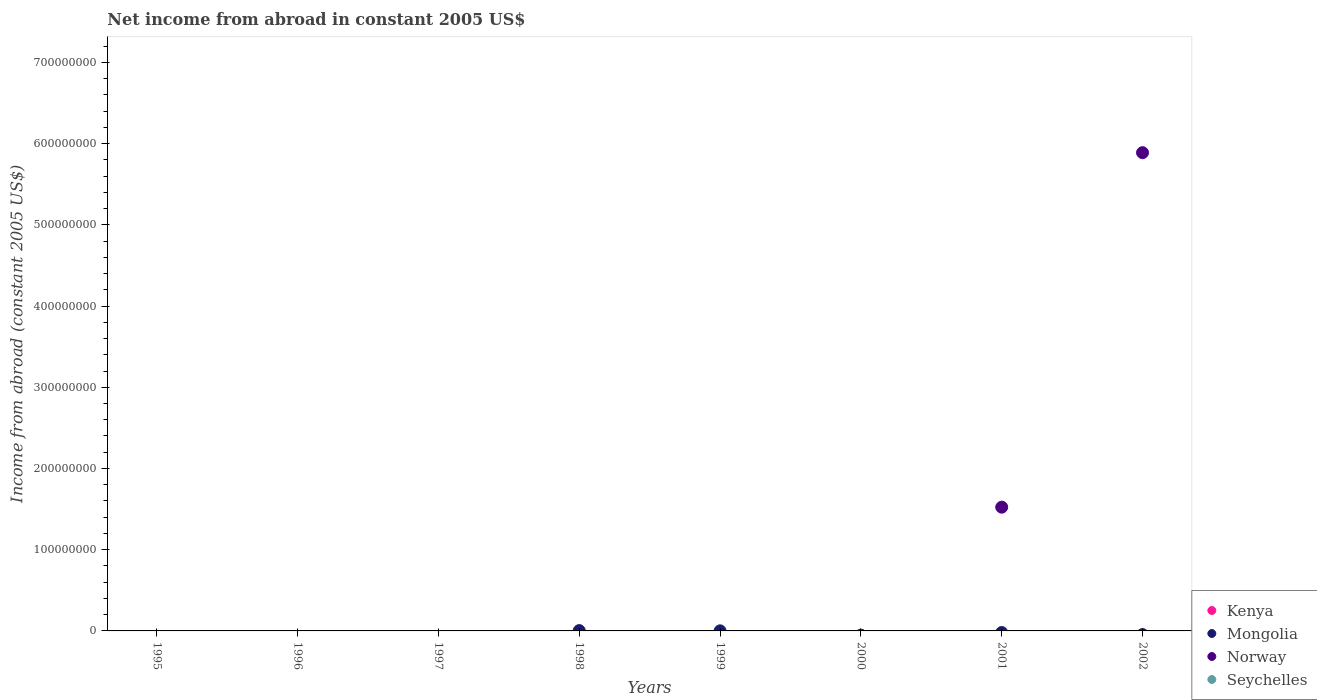Across all years, what is the maximum net income from abroad in Mongolia?
Your response must be concise. 4.00e+05. Across all years, what is the minimum net income from abroad in Norway?
Your response must be concise. 0. In which year was the net income from abroad in Mongolia maximum?
Ensure brevity in your answer.  1998. What is the total net income from abroad in Mongolia in the graph?
Give a very brief answer. 5.00e+05. What is the difference between the net income from abroad in Mongolia in 1995 and the net income from abroad in Seychelles in 1999?
Ensure brevity in your answer.  0. What is the average net income from abroad in Kenya per year?
Ensure brevity in your answer.  0. What is the difference between the highest and the lowest net income from abroad in Mongolia?
Your answer should be very brief. 4.00e+05. Is it the case that in every year, the sum of the net income from abroad in Kenya and net income from abroad in Seychelles  is greater than the sum of net income from abroad in Mongolia and net income from abroad in Norway?
Your answer should be very brief. No. Is it the case that in every year, the sum of the net income from abroad in Norway and net income from abroad in Seychelles  is greater than the net income from abroad in Kenya?
Keep it short and to the point. No. Is the net income from abroad in Seychelles strictly greater than the net income from abroad in Kenya over the years?
Keep it short and to the point. Yes. Is the net income from abroad in Seychelles strictly less than the net income from abroad in Mongolia over the years?
Your answer should be very brief. No. Does the graph contain any zero values?
Your response must be concise. Yes. What is the title of the graph?
Make the answer very short. Net income from abroad in constant 2005 US$. What is the label or title of the Y-axis?
Your response must be concise. Income from abroad (constant 2005 US$). What is the Income from abroad (constant 2005 US$) of Norway in 1995?
Ensure brevity in your answer.  0. What is the Income from abroad (constant 2005 US$) in Kenya in 1996?
Your answer should be very brief. 0. What is the Income from abroad (constant 2005 US$) of Seychelles in 1996?
Provide a succinct answer. 0. What is the Income from abroad (constant 2005 US$) of Mongolia in 1997?
Offer a very short reply. 0. What is the Income from abroad (constant 2005 US$) of Norway in 1997?
Offer a very short reply. 0. What is the Income from abroad (constant 2005 US$) in Seychelles in 1997?
Keep it short and to the point. 0. What is the Income from abroad (constant 2005 US$) in Mongolia in 1998?
Provide a short and direct response. 4.00e+05. What is the Income from abroad (constant 2005 US$) of Norway in 1998?
Provide a succinct answer. 0. What is the Income from abroad (constant 2005 US$) of Seychelles in 1998?
Offer a very short reply. 0. What is the Income from abroad (constant 2005 US$) in Mongolia in 1999?
Provide a succinct answer. 1.00e+05. What is the Income from abroad (constant 2005 US$) of Norway in 1999?
Offer a terse response. 0. What is the Income from abroad (constant 2005 US$) in Seychelles in 1999?
Offer a very short reply. 0. What is the Income from abroad (constant 2005 US$) in Kenya in 2000?
Make the answer very short. 0. What is the Income from abroad (constant 2005 US$) of Norway in 2000?
Make the answer very short. 0. What is the Income from abroad (constant 2005 US$) in Mongolia in 2001?
Offer a terse response. 0. What is the Income from abroad (constant 2005 US$) of Norway in 2001?
Your answer should be very brief. 1.52e+08. What is the Income from abroad (constant 2005 US$) in Seychelles in 2001?
Make the answer very short. 0. What is the Income from abroad (constant 2005 US$) of Kenya in 2002?
Provide a succinct answer. 0. What is the Income from abroad (constant 2005 US$) in Mongolia in 2002?
Provide a succinct answer. 0. What is the Income from abroad (constant 2005 US$) of Norway in 2002?
Make the answer very short. 5.89e+08. Across all years, what is the maximum Income from abroad (constant 2005 US$) in Mongolia?
Your answer should be very brief. 4.00e+05. Across all years, what is the maximum Income from abroad (constant 2005 US$) in Norway?
Your response must be concise. 5.89e+08. Across all years, what is the minimum Income from abroad (constant 2005 US$) in Mongolia?
Ensure brevity in your answer.  0. Across all years, what is the minimum Income from abroad (constant 2005 US$) of Norway?
Offer a terse response. 0. What is the total Income from abroad (constant 2005 US$) of Kenya in the graph?
Make the answer very short. 0. What is the total Income from abroad (constant 2005 US$) in Mongolia in the graph?
Give a very brief answer. 5.00e+05. What is the total Income from abroad (constant 2005 US$) of Norway in the graph?
Your answer should be compact. 7.41e+08. What is the total Income from abroad (constant 2005 US$) in Seychelles in the graph?
Make the answer very short. 0. What is the difference between the Income from abroad (constant 2005 US$) of Mongolia in 1998 and that in 1999?
Offer a terse response. 3.00e+05. What is the difference between the Income from abroad (constant 2005 US$) in Norway in 2001 and that in 2002?
Make the answer very short. -4.36e+08. What is the difference between the Income from abroad (constant 2005 US$) of Mongolia in 1998 and the Income from abroad (constant 2005 US$) of Norway in 2001?
Offer a very short reply. -1.52e+08. What is the difference between the Income from abroad (constant 2005 US$) of Mongolia in 1998 and the Income from abroad (constant 2005 US$) of Norway in 2002?
Your answer should be very brief. -5.88e+08. What is the difference between the Income from abroad (constant 2005 US$) in Mongolia in 1999 and the Income from abroad (constant 2005 US$) in Norway in 2001?
Provide a short and direct response. -1.52e+08. What is the difference between the Income from abroad (constant 2005 US$) of Mongolia in 1999 and the Income from abroad (constant 2005 US$) of Norway in 2002?
Give a very brief answer. -5.89e+08. What is the average Income from abroad (constant 2005 US$) in Mongolia per year?
Your answer should be compact. 6.25e+04. What is the average Income from abroad (constant 2005 US$) in Norway per year?
Offer a terse response. 9.26e+07. What is the ratio of the Income from abroad (constant 2005 US$) in Mongolia in 1998 to that in 1999?
Your answer should be very brief. 4. What is the ratio of the Income from abroad (constant 2005 US$) in Norway in 2001 to that in 2002?
Offer a very short reply. 0.26. What is the difference between the highest and the lowest Income from abroad (constant 2005 US$) in Mongolia?
Your answer should be very brief. 4.00e+05. What is the difference between the highest and the lowest Income from abroad (constant 2005 US$) in Norway?
Your answer should be compact. 5.89e+08. 